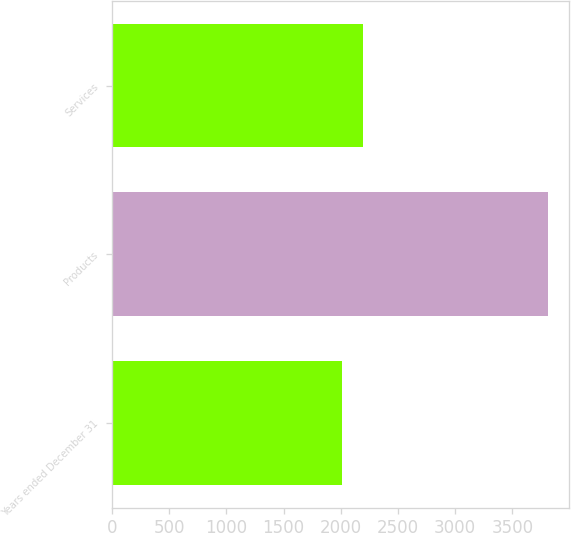<chart> <loc_0><loc_0><loc_500><loc_500><bar_chart><fcel>Years ended December 31<fcel>Products<fcel>Services<nl><fcel>2014<fcel>3807<fcel>2193.3<nl></chart> 